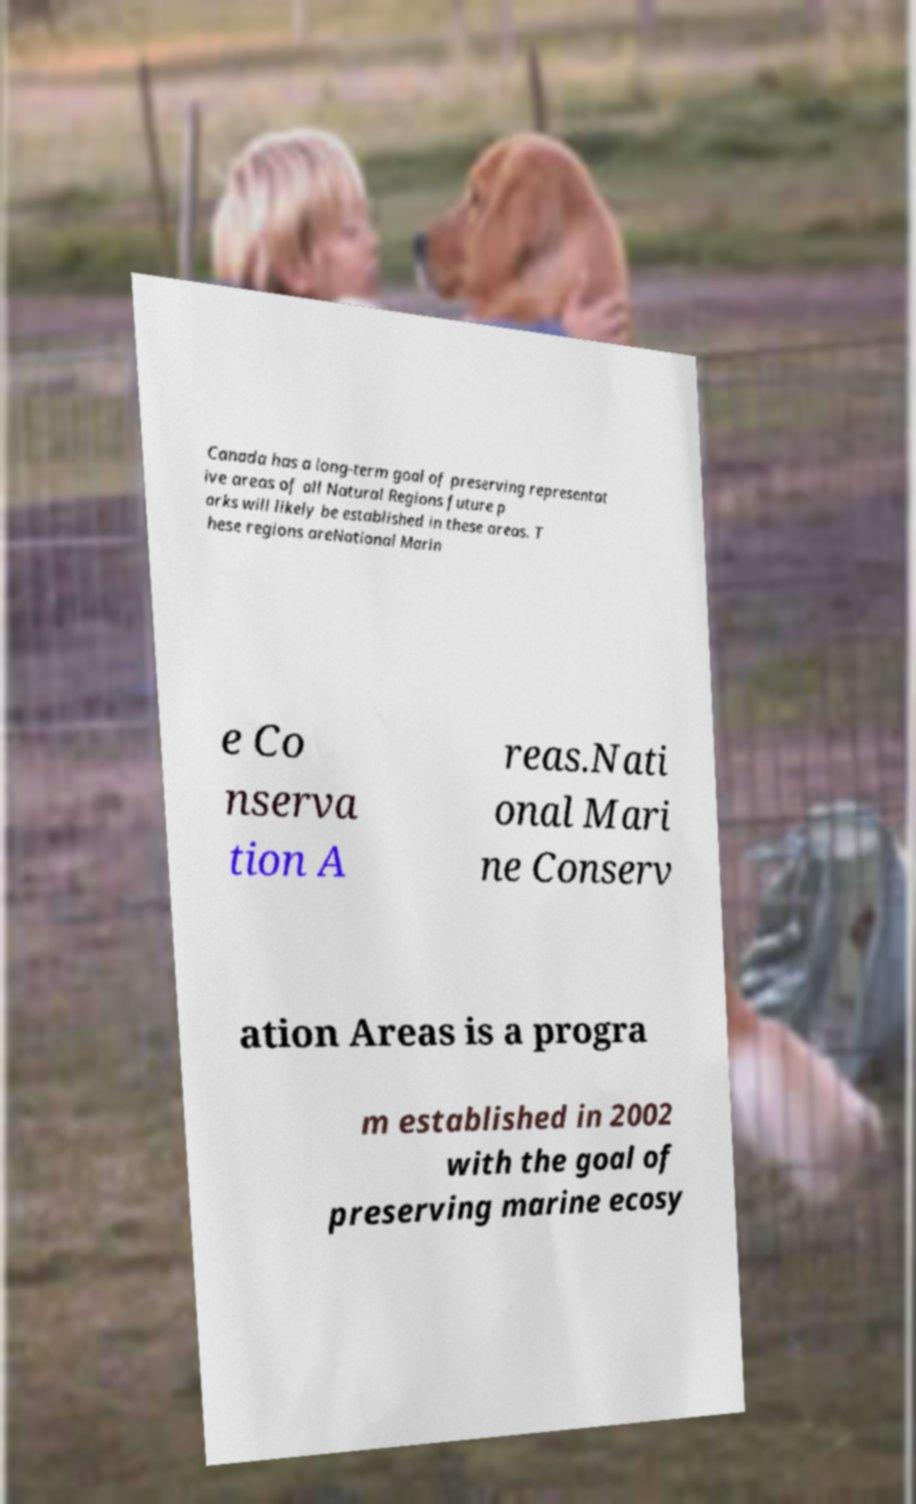There's text embedded in this image that I need extracted. Can you transcribe it verbatim? Canada has a long-term goal of preserving representat ive areas of all Natural Regions future p arks will likely be established in these areas. T hese regions areNational Marin e Co nserva tion A reas.Nati onal Mari ne Conserv ation Areas is a progra m established in 2002 with the goal of preserving marine ecosy 